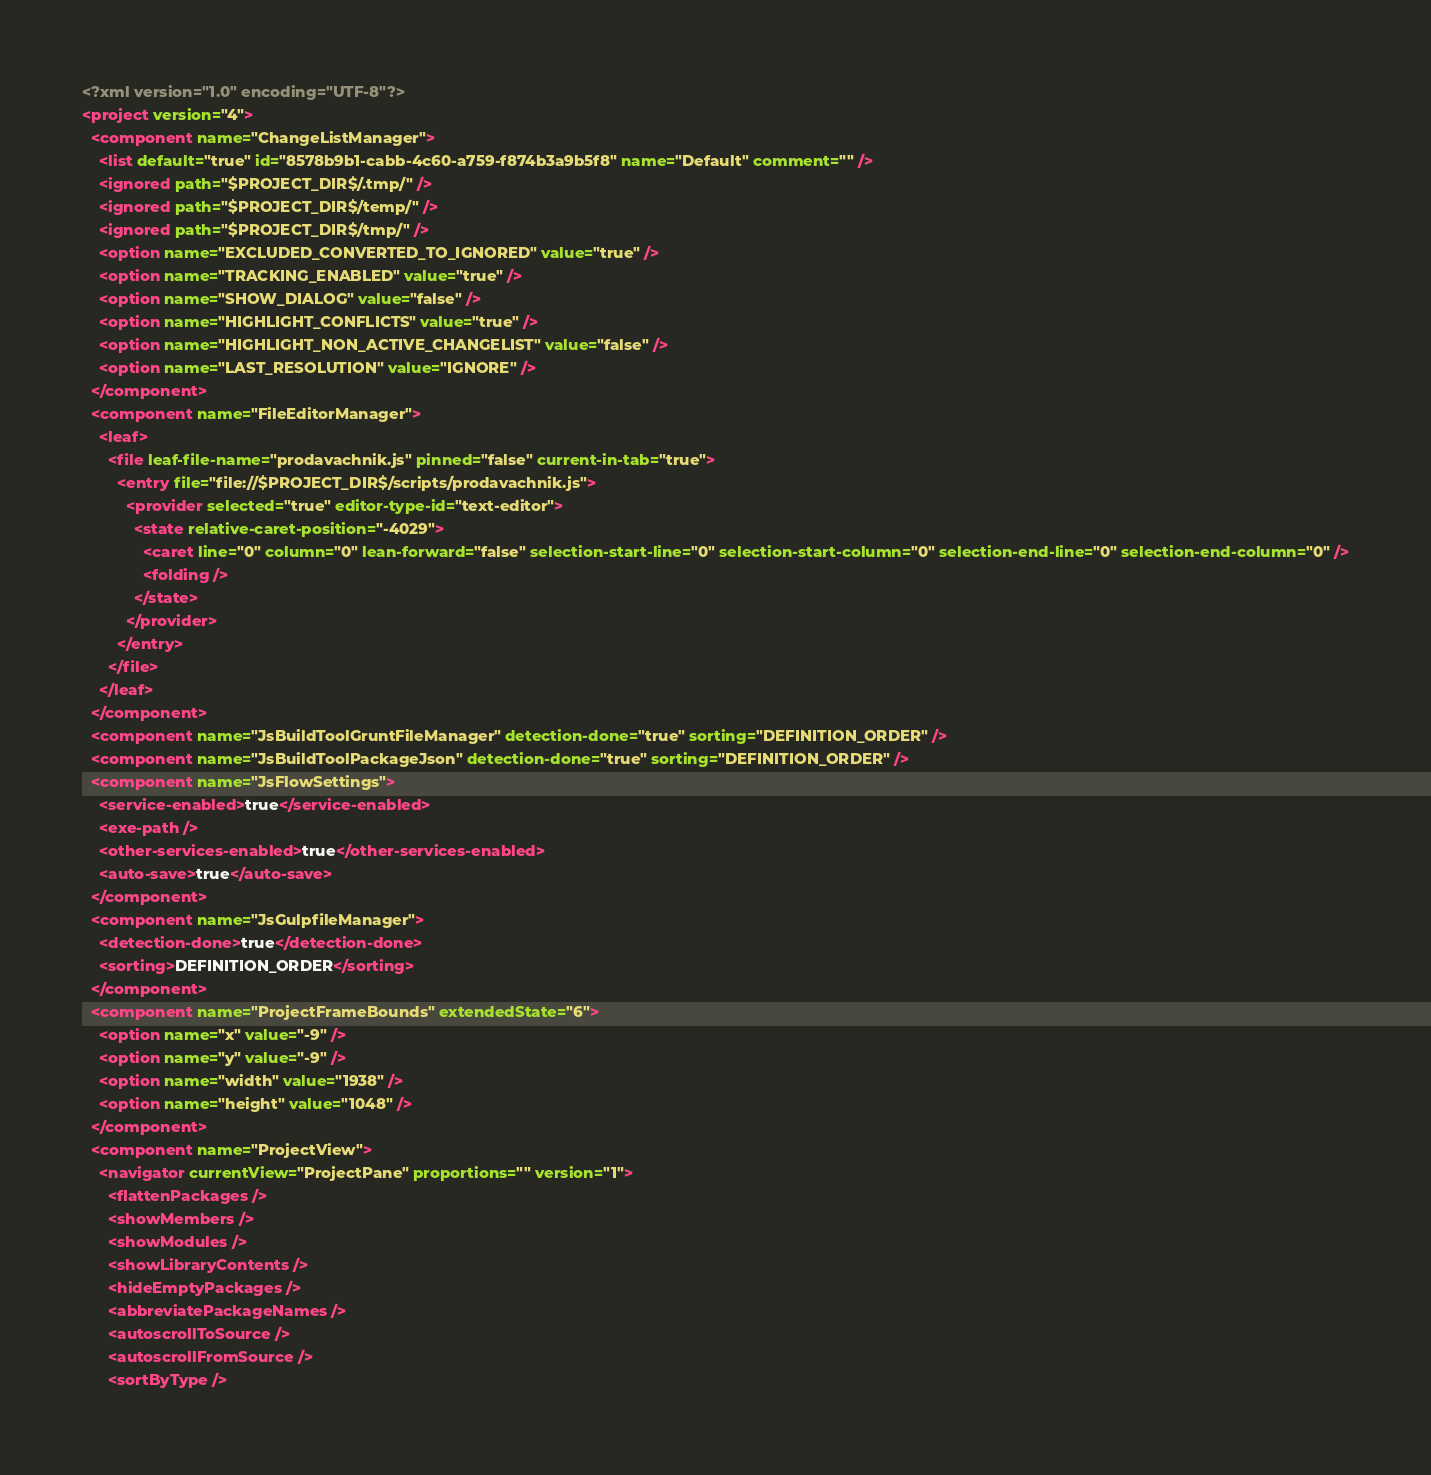<code> <loc_0><loc_0><loc_500><loc_500><_XML_><?xml version="1.0" encoding="UTF-8"?>
<project version="4">
  <component name="ChangeListManager">
    <list default="true" id="8578b9b1-cabb-4c60-a759-f874b3a9b5f8" name="Default" comment="" />
    <ignored path="$PROJECT_DIR$/.tmp/" />
    <ignored path="$PROJECT_DIR$/temp/" />
    <ignored path="$PROJECT_DIR$/tmp/" />
    <option name="EXCLUDED_CONVERTED_TO_IGNORED" value="true" />
    <option name="TRACKING_ENABLED" value="true" />
    <option name="SHOW_DIALOG" value="false" />
    <option name="HIGHLIGHT_CONFLICTS" value="true" />
    <option name="HIGHLIGHT_NON_ACTIVE_CHANGELIST" value="false" />
    <option name="LAST_RESOLUTION" value="IGNORE" />
  </component>
  <component name="FileEditorManager">
    <leaf>
      <file leaf-file-name="prodavachnik.js" pinned="false" current-in-tab="true">
        <entry file="file://$PROJECT_DIR$/scripts/prodavachnik.js">
          <provider selected="true" editor-type-id="text-editor">
            <state relative-caret-position="-4029">
              <caret line="0" column="0" lean-forward="false" selection-start-line="0" selection-start-column="0" selection-end-line="0" selection-end-column="0" />
              <folding />
            </state>
          </provider>
        </entry>
      </file>
    </leaf>
  </component>
  <component name="JsBuildToolGruntFileManager" detection-done="true" sorting="DEFINITION_ORDER" />
  <component name="JsBuildToolPackageJson" detection-done="true" sorting="DEFINITION_ORDER" />
  <component name="JsFlowSettings">
    <service-enabled>true</service-enabled>
    <exe-path />
    <other-services-enabled>true</other-services-enabled>
    <auto-save>true</auto-save>
  </component>
  <component name="JsGulpfileManager">
    <detection-done>true</detection-done>
    <sorting>DEFINITION_ORDER</sorting>
  </component>
  <component name="ProjectFrameBounds" extendedState="6">
    <option name="x" value="-9" />
    <option name="y" value="-9" />
    <option name="width" value="1938" />
    <option name="height" value="1048" />
  </component>
  <component name="ProjectView">
    <navigator currentView="ProjectPane" proportions="" version="1">
      <flattenPackages />
      <showMembers />
      <showModules />
      <showLibraryContents />
      <hideEmptyPackages />
      <abbreviatePackageNames />
      <autoscrollToSource />
      <autoscrollFromSource />
      <sortByType /></code> 